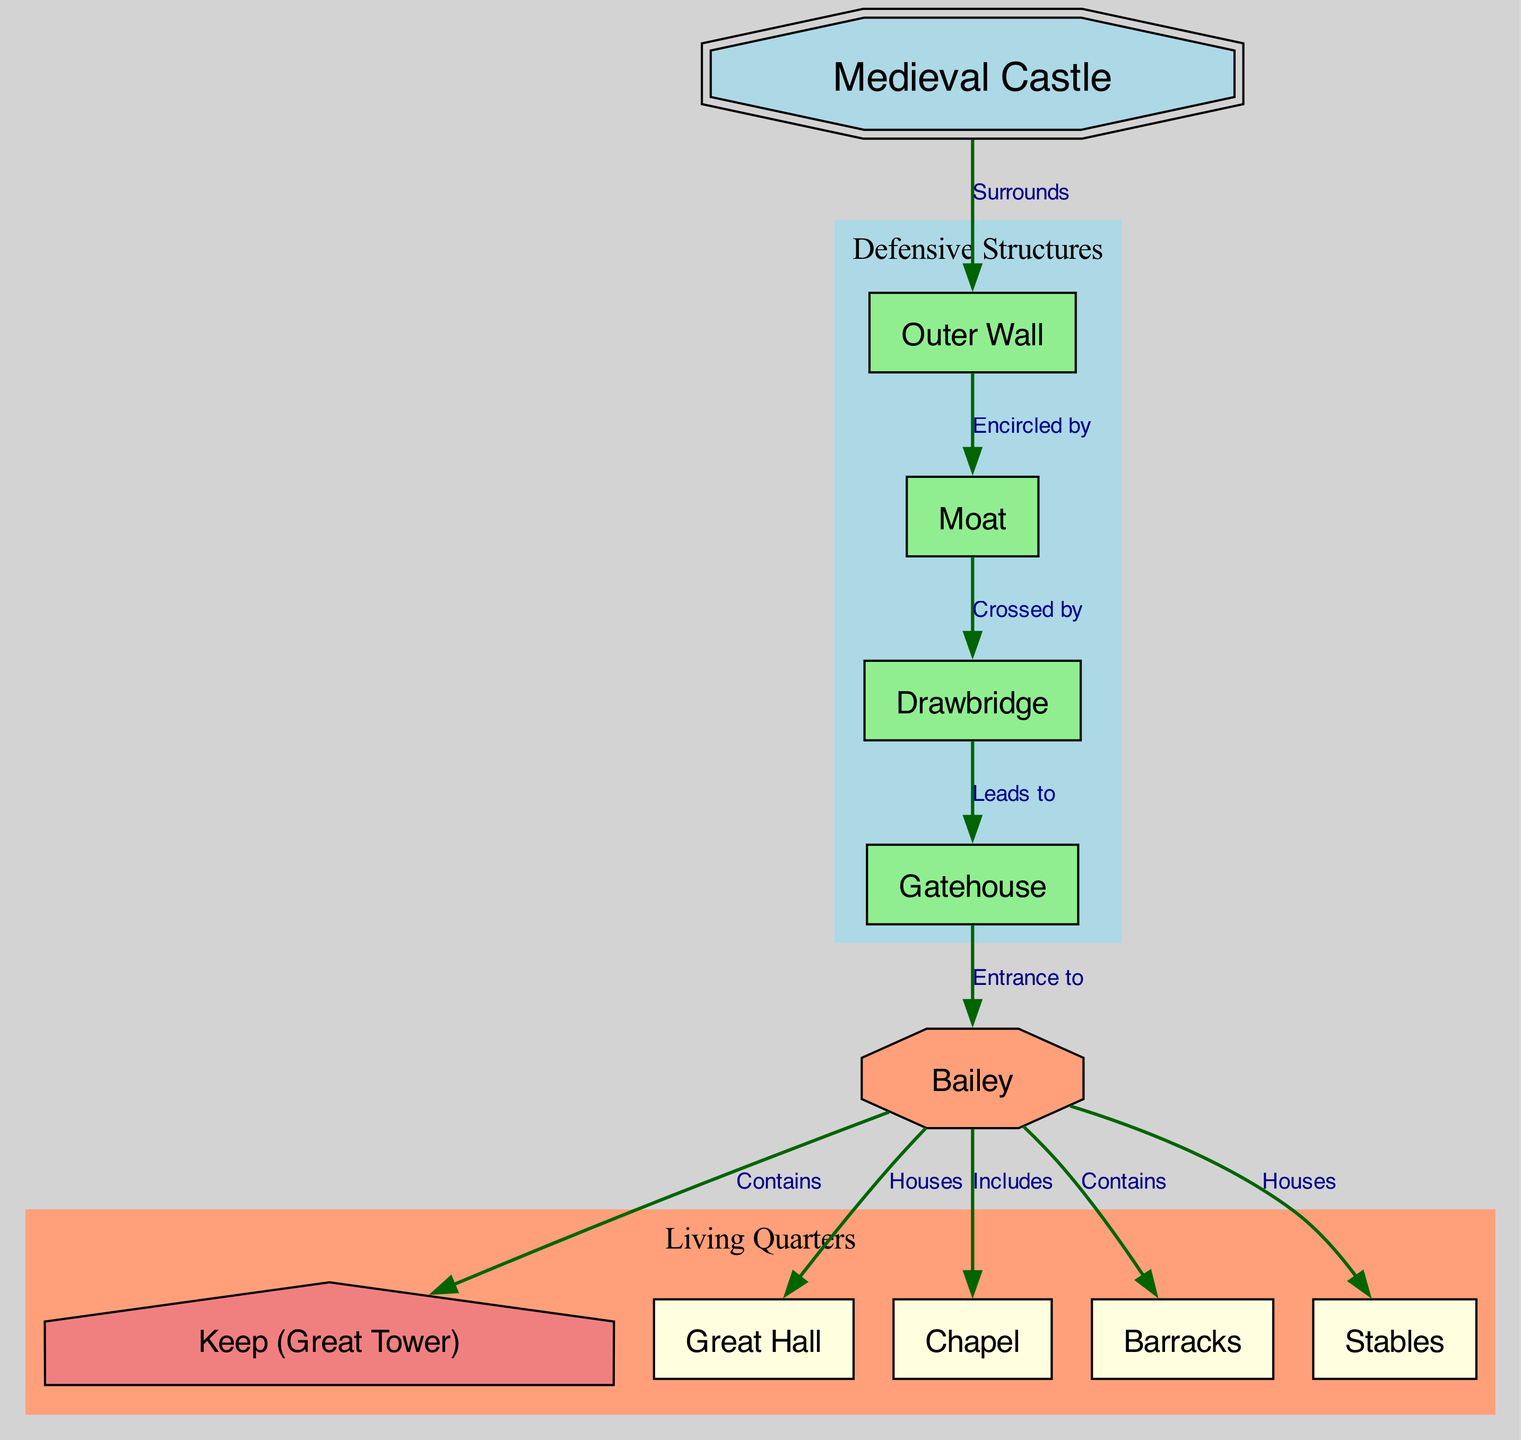What surrounds the medieval castle? The diagram states that the "Outer Wall" surrounds the "Medieval Castle", indicating the first defensive structure in the layout.
Answer: Outer Wall What encircles the outer wall? According to the diagram, the "Moat" is noted as being encircled by the "Outer Wall", showing the relationship between these two defensive features.
Answer: Moat How many living quarters are shown in the diagram? By counting the nodes labeled as living quarters – "Keep", "Great Hall", "Chapel", "Barracks", and "Stables" – we find there are five distinct living quarters included.
Answer: 5 What does the drawbridge lead to? The diagram specifies that the "Drawbridge" leads to the "Gatehouse", indicating a clear path for access into the castle complex.
Answer: Gatehouse Which structure contains the keep? The diagram illustrates that the "Bailey" contains the "Keep", making it a central feature within the living quarter area of the castle layout.
Answer: Keep Where are the barracks located? The relationship in the diagram shows that the "Barracks" are included in the "Bailey", confirming their placement within the castle grounds.
Answer: Bailey What crosses the moat? The diagram indicates that the "Drawbridge" crosses the "Moat", serving as both a defensive and access feature to the castle.
Answer: Drawbridge Which feature directly houses the great hall? The "Bailey" is identified in the diagram as the structure that houses the "Great Hall", linking living quarters with other areas.
Answer: Bailey How is the castle's defensive structure categorized? The diagram categorizes the defensive structures into a cluster labeled "Defensive Structures", which includes "Outer Wall", "Moat", "Drawbridge", and "Gatehouse".
Answer: Defensive Structures What is the significance of the chapel in the layout? The diagram indicates that the "Chapel" is included in the "Bailey", suggesting it serves as a place of worship within the living quarters section of the castle.
Answer: Bailey 